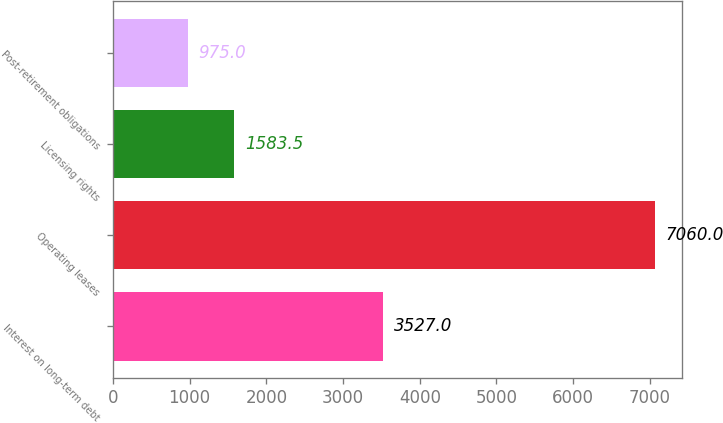Convert chart to OTSL. <chart><loc_0><loc_0><loc_500><loc_500><bar_chart><fcel>Interest on long-term debt<fcel>Operating leases<fcel>Licensing rights<fcel>Post-retirement obligations<nl><fcel>3527<fcel>7060<fcel>1583.5<fcel>975<nl></chart> 